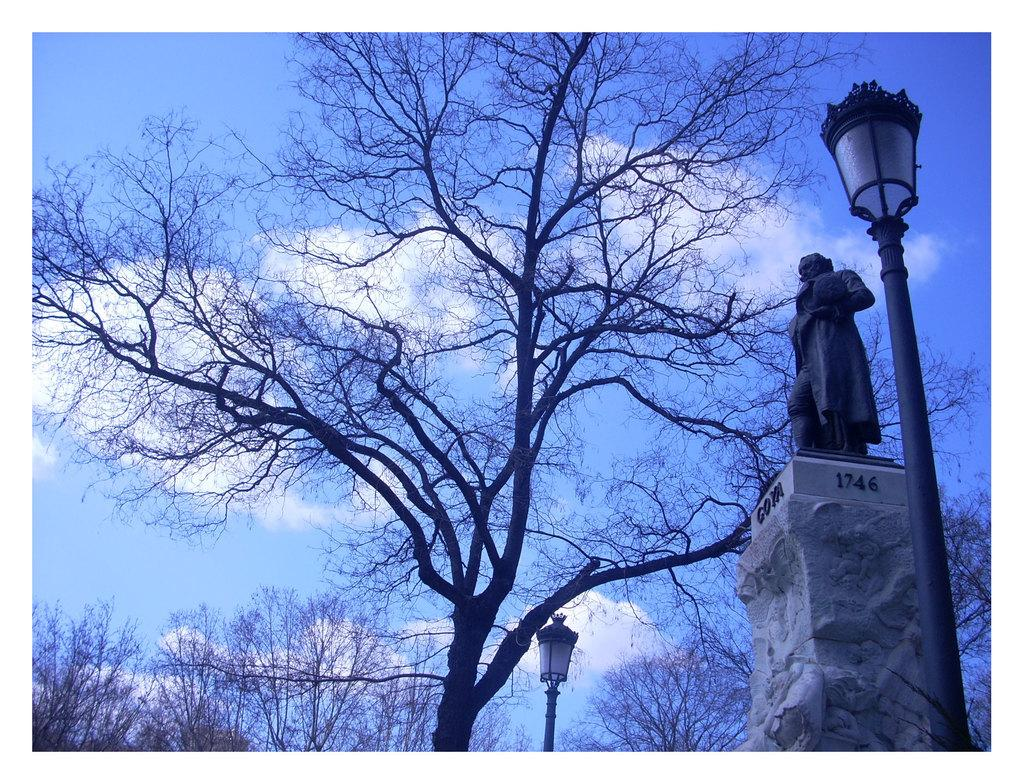What type of natural elements can be seen in the image? There are trees in the image. What man-made structures are present in the image? There are poles with lights and a statue on a pillar in the image. What is written or engraved on the statue? The statue has some text on it. What is visible in the background of the image? The sky is visible in the image, and clouds are present in the sky. How many cars are parked near the statue in the image? There are no cars present in the image; it only features trees, poles with lights, a statue, and the sky with clouds. 